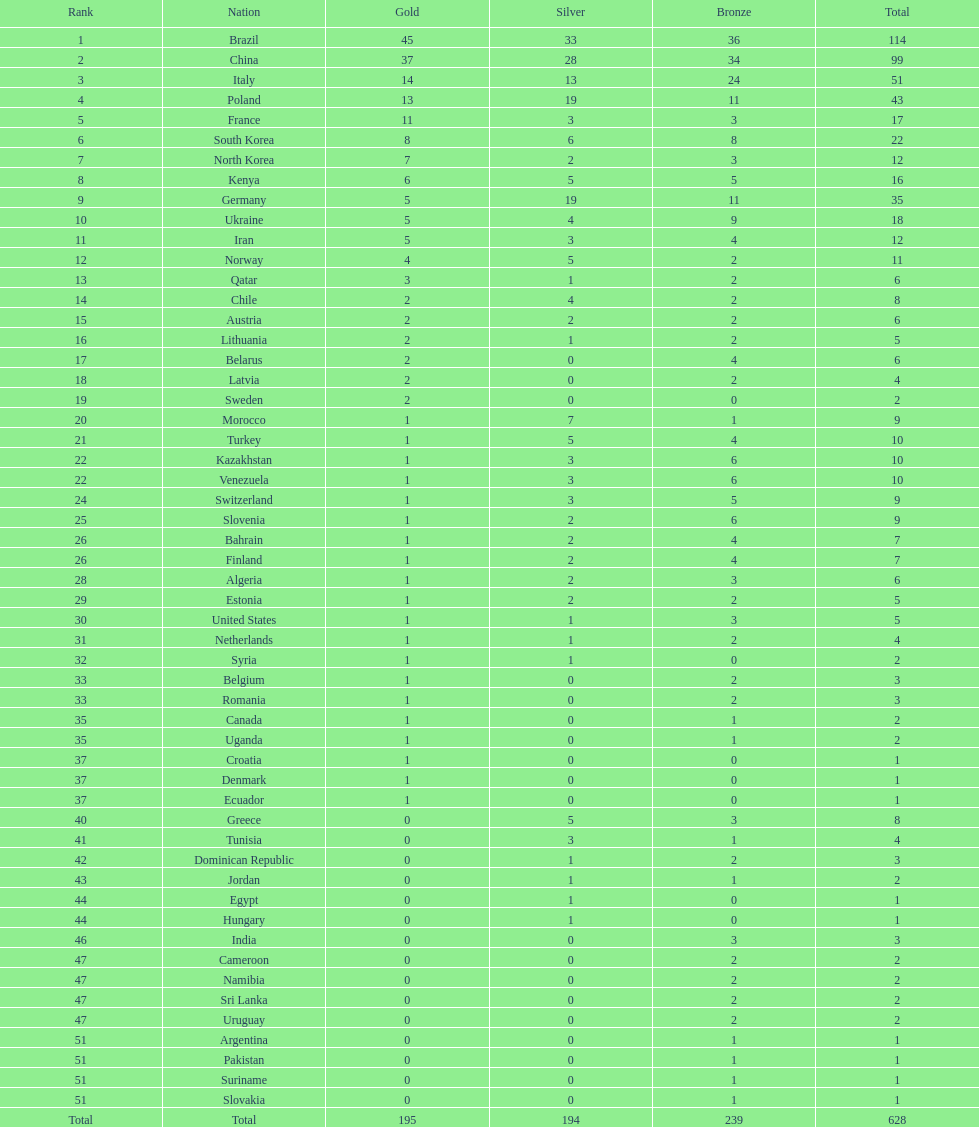How many gold medals did germany obtain? 5. 